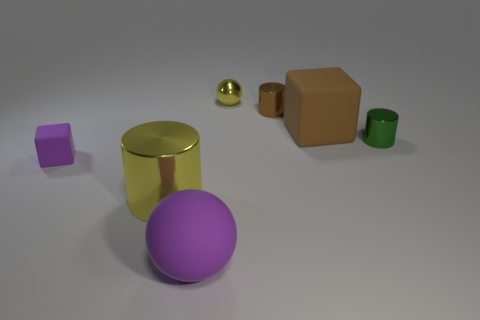Is there anything else that has the same size as the brown metallic object?
Your response must be concise. Yes. Is the material of the tiny ball the same as the cube left of the yellow cylinder?
Offer a terse response. No. What number of other things are there of the same shape as the tiny rubber object?
Make the answer very short. 1. There is a small metal sphere; is its color the same as the small shiny cylinder behind the brown matte object?
Ensure brevity in your answer.  No. What is the shape of the tiny thing right of the matte block that is behind the small purple cube?
Your answer should be very brief. Cylinder. The rubber thing that is the same color as the matte sphere is what size?
Your answer should be very brief. Small. Does the yellow object behind the green cylinder have the same shape as the big yellow object?
Your answer should be very brief. No. Are there more large purple balls to the left of the small purple block than small green metallic cylinders left of the small brown cylinder?
Ensure brevity in your answer.  No. How many tiny shiny things are in front of the tiny brown cylinder that is in front of the tiny yellow sphere?
Keep it short and to the point. 1. There is another thing that is the same color as the tiny matte object; what is its material?
Make the answer very short. Rubber. 